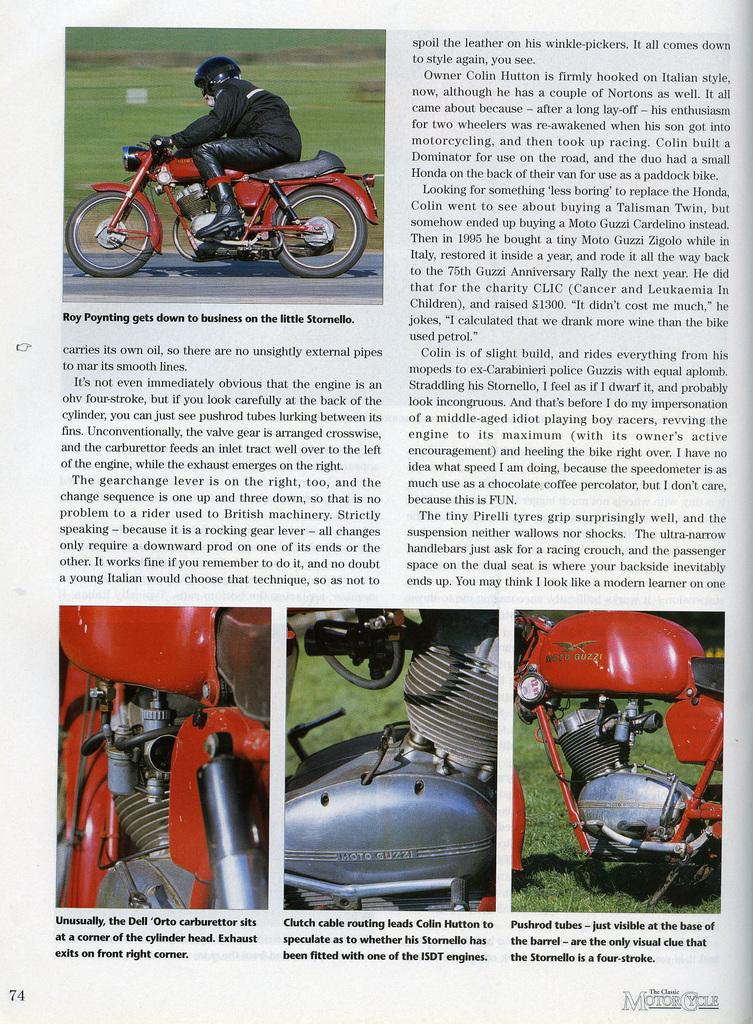What is depicted on the paper in the image? The paper contains an image of a person wearing a helmet and riding a motorbike. What is the person riding in the image? The person is riding a motorbike in the image. Where is the motorbike located in the image? The motorbike is on a road in the image. What type of vegetation is visible in the image? Grass is visible in the image. What else can be seen in the image besides the motorbike and the person? There are bike parts in the image. Is there any text on the paper in the image? Yes, there is text on the paper in the image. How many snakes are slithering across the road in the image? There are no snakes present in the image; it features a person riding a motorbike on a road. What type of health advice is given on the paper in the image? There is no health advice present on the paper in the image; it contains an image of a person riding a motorbike and some text. 